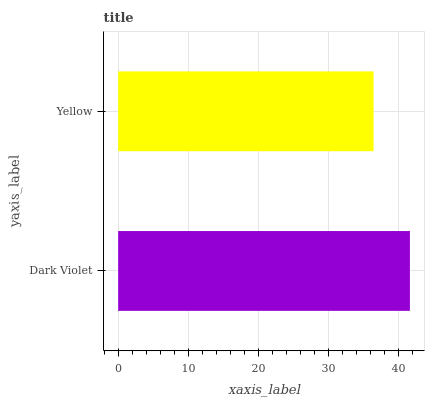Is Yellow the minimum?
Answer yes or no. Yes. Is Dark Violet the maximum?
Answer yes or no. Yes. Is Yellow the maximum?
Answer yes or no. No. Is Dark Violet greater than Yellow?
Answer yes or no. Yes. Is Yellow less than Dark Violet?
Answer yes or no. Yes. Is Yellow greater than Dark Violet?
Answer yes or no. No. Is Dark Violet less than Yellow?
Answer yes or no. No. Is Dark Violet the high median?
Answer yes or no. Yes. Is Yellow the low median?
Answer yes or no. Yes. Is Yellow the high median?
Answer yes or no. No. Is Dark Violet the low median?
Answer yes or no. No. 